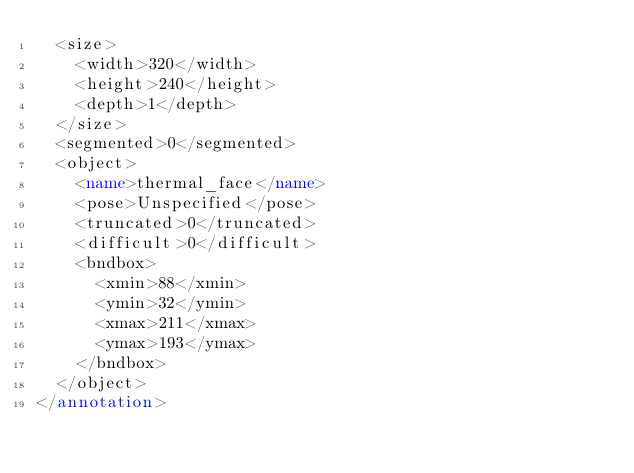<code> <loc_0><loc_0><loc_500><loc_500><_XML_>	<size>
		<width>320</width>
		<height>240</height>
		<depth>1</depth>
	</size>
	<segmented>0</segmented>
	<object>
		<name>thermal_face</name>
		<pose>Unspecified</pose>
		<truncated>0</truncated>
		<difficult>0</difficult>
		<bndbox>
			<xmin>88</xmin>
			<ymin>32</ymin>
			<xmax>211</xmax>
			<ymax>193</ymax>
		</bndbox>
	</object>
</annotation>
</code> 